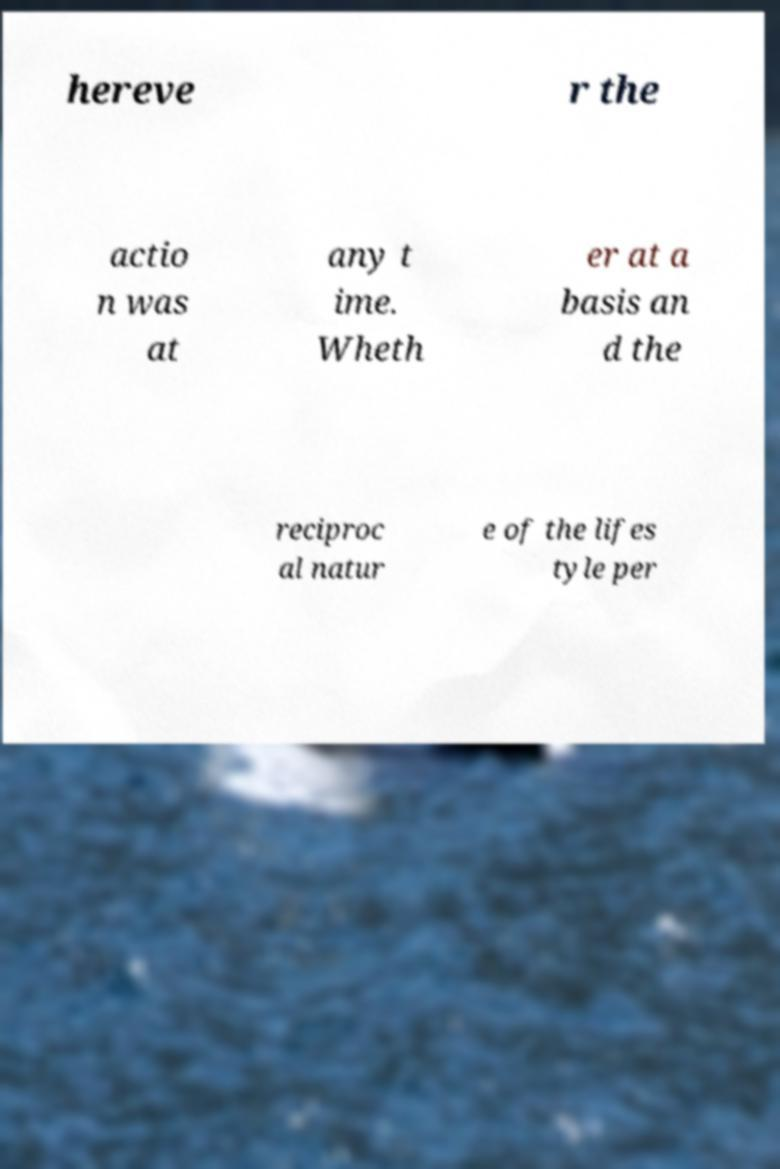Please read and relay the text visible in this image. What does it say? hereve r the actio n was at any t ime. Wheth er at a basis an d the reciproc al natur e of the lifes tyle per 